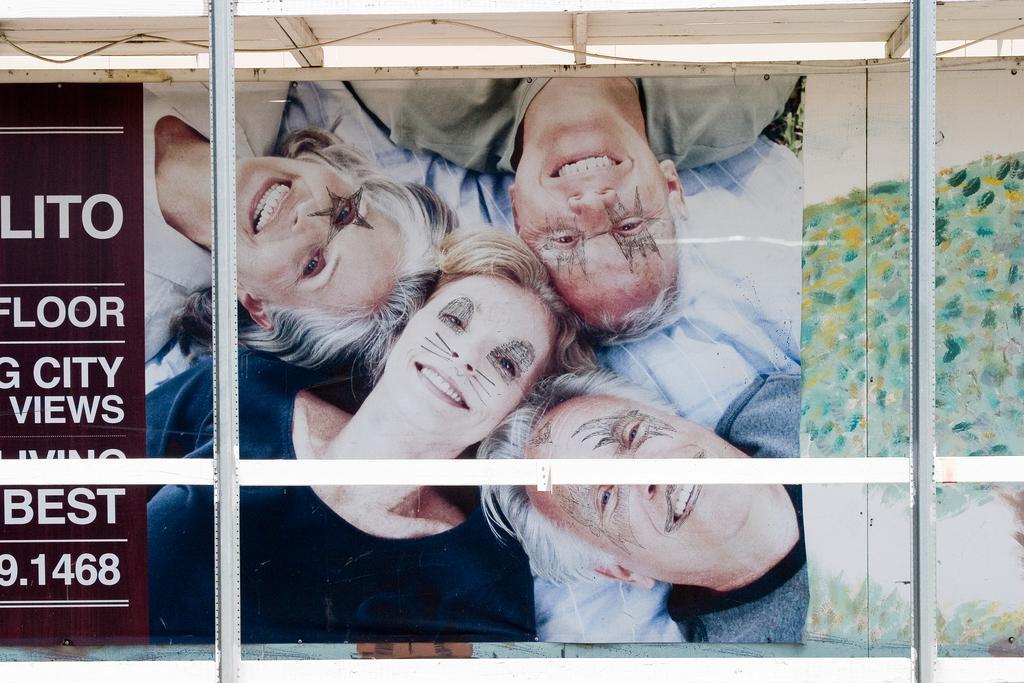Please provide a concise description of this image. In this image we can see a group of people are smiling, they are wearing a face painting, on the left corner there is some matter written on it. 